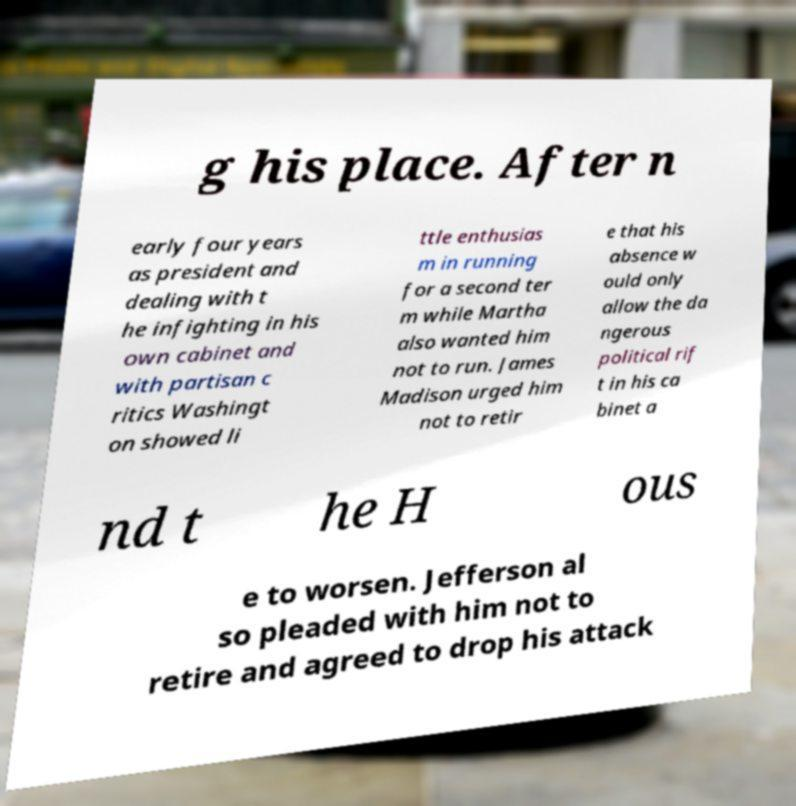Can you accurately transcribe the text from the provided image for me? g his place. After n early four years as president and dealing with t he infighting in his own cabinet and with partisan c ritics Washingt on showed li ttle enthusias m in running for a second ter m while Martha also wanted him not to run. James Madison urged him not to retir e that his absence w ould only allow the da ngerous political rif t in his ca binet a nd t he H ous e to worsen. Jefferson al so pleaded with him not to retire and agreed to drop his attack 